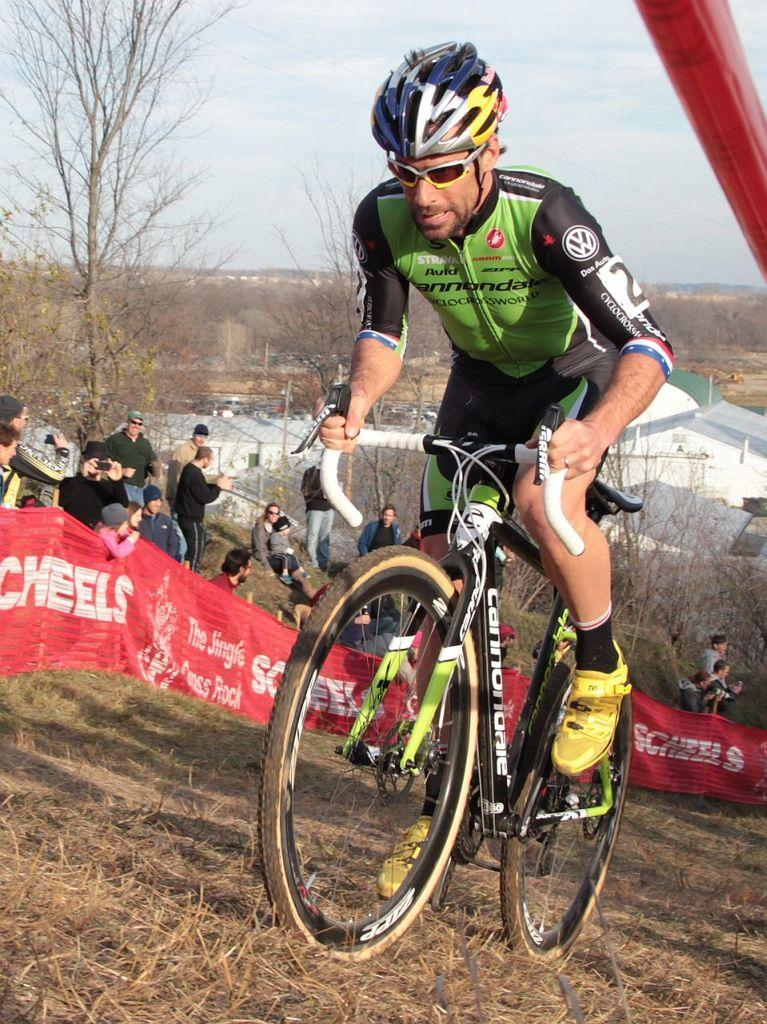What type of vegetation is present in the image? There are dry trees in the image. What else can be seen in the sky in the image? The sky is visible in the image. What are the people in the image doing? There are people sitting and standing in the image. What mode of transportation is being used by a person in the image? A man is riding a bicycle in the image. What type of stamp can be seen on the dry trees in the image? There is no stamp present on the dry trees in the image. How does the sun affect the sand in the image? There is no sand present in the image, so the sun's effect on sand cannot be observed. 